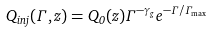<formula> <loc_0><loc_0><loc_500><loc_500>Q _ { i n j } ( \Gamma , z ) = Q _ { 0 } ( z ) \Gamma ^ { - \gamma _ { g } } e ^ { - \Gamma / \Gamma _ { \max } }</formula> 